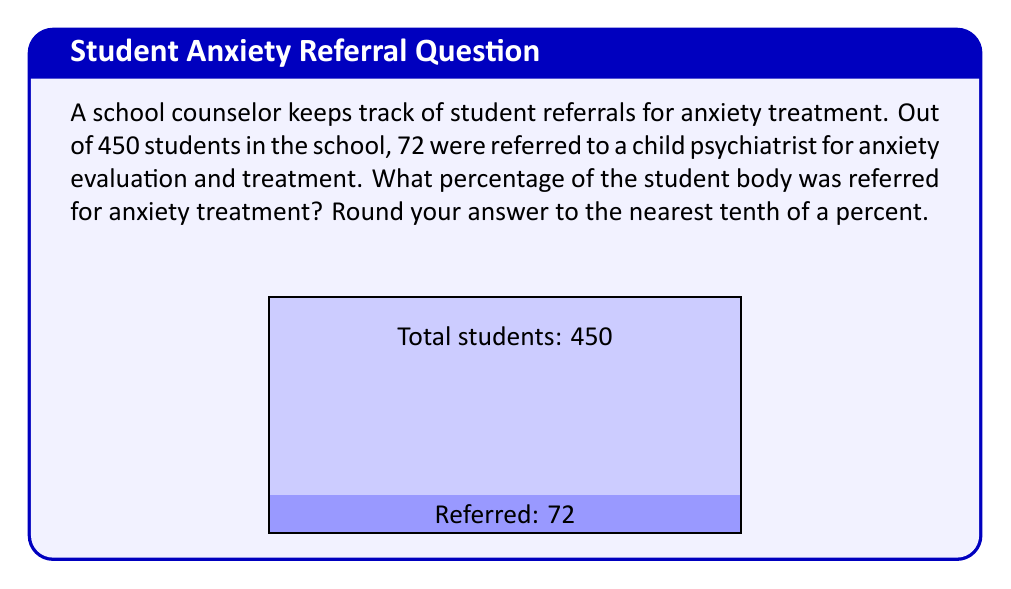Can you solve this math problem? To calculate the percentage of students referred for anxiety treatment, we need to:

1. Identify the total number of students and the number of referred students:
   - Total students: 450
   - Referred students: 72

2. Use the formula for percentage:
   $$ \text{Percentage} = \frac{\text{Part}}{\text{Whole}} \times 100\% $$

3. Plug in the values:
   $$ \text{Percentage} = \frac{72}{450} \times 100\% $$

4. Perform the division:
   $$ \frac{72}{450} = 0.16 $$

5. Multiply by 100% to get the percentage:
   $$ 0.16 \times 100\% = 16\% $$

6. Round to the nearest tenth of a percent:
   16% is already rounded to the nearest tenth, so no further rounding is necessary.

Therefore, 16.0% of the student body was referred for anxiety treatment.
Answer: 16.0% 